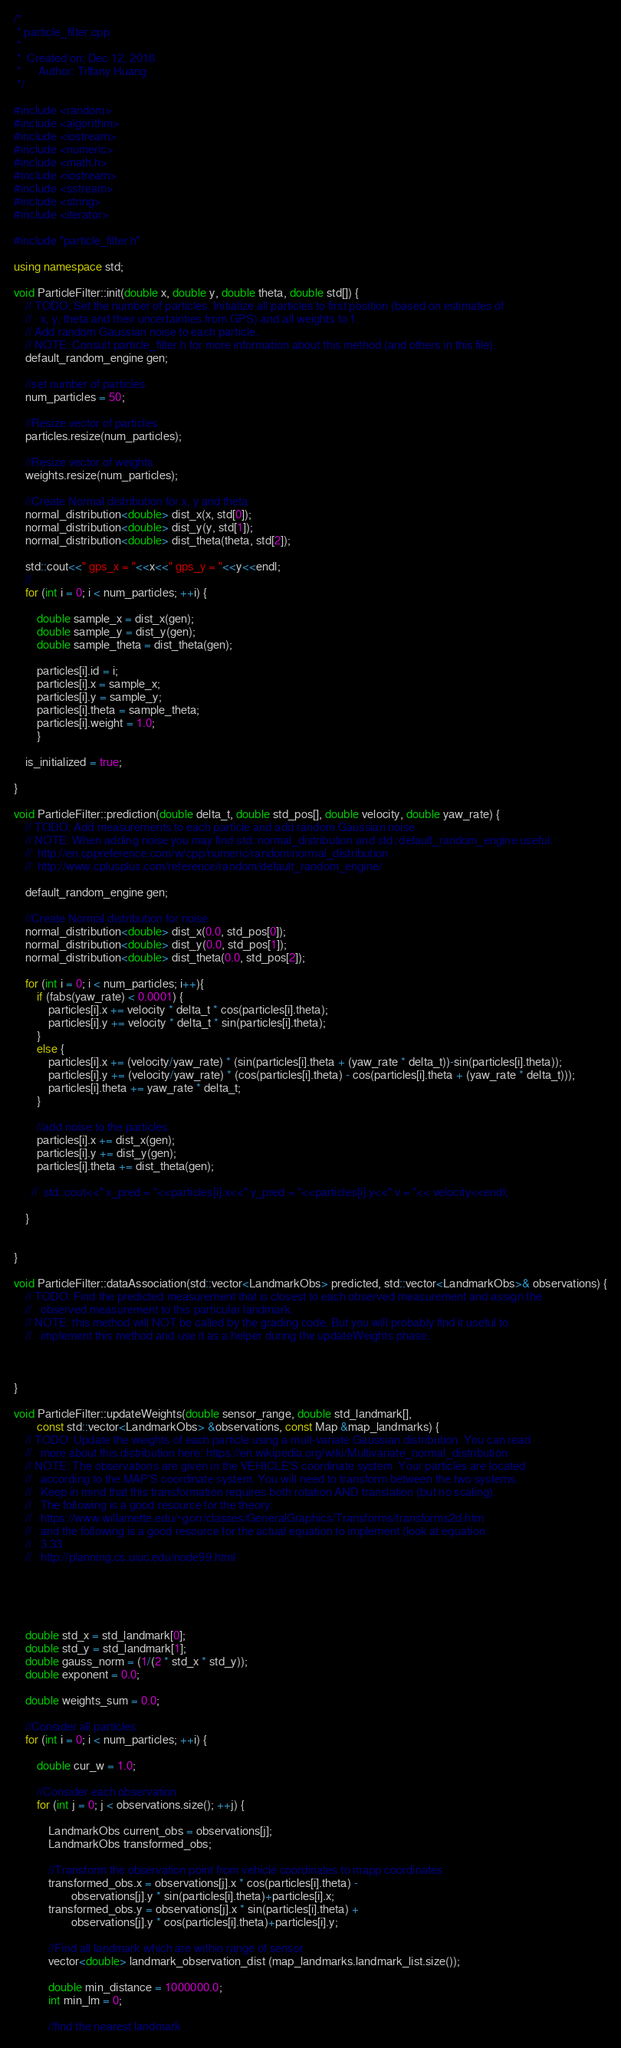<code> <loc_0><loc_0><loc_500><loc_500><_C++_>/*
 * particle_filter.cpp
 *
 *  Created on: Dec 12, 2016
 *      Author: Tiffany Huang
 */

#include <random>
#include <algorithm>
#include <iostream>
#include <numeric>
#include <math.h> 
#include <iostream>
#include <sstream>
#include <string>
#include <iterator>

#include "particle_filter.h"

using namespace std;

void ParticleFilter::init(double x, double y, double theta, double std[]) {
	// TODO: Set the number of particles. Initialize all particles to first position (based on estimates of 
	//   x, y, theta and their uncertainties from GPS) and all weights to 1. 
	// Add random Gaussian noise to each particle.
	// NOTE: Consult particle_filter.h for more information about this method (and others in this file).
    default_random_engine gen;

    //set number of particles
    num_particles = 50;

    //Resize vector of particles
    particles.resize(num_particles);

    //Resize vector of weights
    weights.resize(num_particles);

    //Create Normal distribution for x, y and theta
    normal_distribution<double> dist_x(x, std[0]);
    normal_distribution<double> dist_y(y, std[1]);
    normal_distribution<double> dist_theta(theta, std[2]);

    std::cout<<" gps_x = "<<x<<" gps_y = "<<y<<endl;
    //
    for (int i = 0; i < num_particles; ++i) {

        double sample_x = dist_x(gen);
        double sample_y = dist_y(gen);
        double sample_theta = dist_theta(gen);

        particles[i].id = i;
        particles[i].x = sample_x;
        particles[i].y = sample_y;
        particles[i].theta = sample_theta;
        particles[i].weight = 1.0;
        }

    is_initialized = true;

}

void ParticleFilter::prediction(double delta_t, double std_pos[], double velocity, double yaw_rate) {
	// TODO: Add measurements to each particle and add random Gaussian noise.
	// NOTE: When adding noise you may find std::normal_distribution and std::default_random_engine useful.
	//  http://en.cppreference.com/w/cpp/numeric/random/normal_distribution
	//  http://www.cplusplus.com/reference/random/default_random_engine/

    default_random_engine gen;

    //Create Normal distribution for noise
    normal_distribution<double> dist_x(0.0, std_pos[0]);
    normal_distribution<double> dist_y(0.0, std_pos[1]);
    normal_distribution<double> dist_theta(0.0, std_pos[2]);

    for (int i = 0; i < num_particles; i++){
        if (fabs(yaw_rate) < 0.0001) {
            particles[i].x += velocity * delta_t * cos(particles[i].theta);
            particles[i].y += velocity * delta_t * sin(particles[i].theta);
        }
        else {
            particles[i].x += (velocity/yaw_rate) * (sin(particles[i].theta + (yaw_rate * delta_t))-sin(particles[i].theta));
            particles[i].y += (velocity/yaw_rate) * (cos(particles[i].theta) - cos(particles[i].theta + (yaw_rate * delta_t)));
            particles[i].theta += yaw_rate * delta_t;
        }

        //add noise to the particles
        particles[i].x += dist_x(gen);
        particles[i].y += dist_y(gen);
        particles[i].theta += dist_theta(gen);

      //  std::cout<<" x_pred = "<<particles[i].x<<" y_pred = "<<particles[i].y<<" v = "<< velocity<<endl;

    }


}

void ParticleFilter::dataAssociation(std::vector<LandmarkObs> predicted, std::vector<LandmarkObs>& observations) {
	// TODO: Find the predicted measurement that is closest to each observed measurement and assign the 
	//   observed measurement to this particular landmark.
	// NOTE: this method will NOT be called by the grading code. But you will probably find it useful to 
	//   implement this method and use it as a helper during the updateWeights phase.



}

void ParticleFilter::updateWeights(double sensor_range, double std_landmark[], 
		const std::vector<LandmarkObs> &observations, const Map &map_landmarks) {
	// TODO: Update the weights of each particle using a mult-variate Gaussian distribution. You can read
	//   more about this distribution here: https://en.wikipedia.org/wiki/Multivariate_normal_distribution
	// NOTE: The observations are given in the VEHICLE'S coordinate system. Your particles are located
	//   according to the MAP'S coordinate system. You will need to transform between the two systems.
	//   Keep in mind that this transformation requires both rotation AND translation (but no scaling).
	//   The following is a good resource for the theory:
	//   https://www.willamette.edu/~gorr/classes/GeneralGraphics/Transforms/transforms2d.htm
	//   and the following is a good resource for the actual equation to implement (look at equation 
	//   3.33
	//   http://planning.cs.uiuc.edu/node99.html





    double std_x = std_landmark[0];
    double std_y = std_landmark[1];
    double gauss_norm = (1/(2 * std_x * std_y));
    double exponent = 0.0;

    double weights_sum = 0.0;

    //Consider all particles
    for (int i = 0; i < num_particles; ++i) {

        double cur_w = 1.0;

        //Consider each observation
        for (int j = 0; j < observations.size(); ++j) {

            LandmarkObs current_obs = observations[j];
            LandmarkObs transformed_obs;

            //Transform the observation point from vehicle coordinates to mapp coordinates
            transformed_obs.x = observations[j].x * cos(particles[i].theta) -
                    observations[j].y * sin(particles[i].theta)+particles[i].x;
            transformed_obs.y = observations[j].x * sin(particles[i].theta) +
                    observations[j].y * cos(particles[i].theta)+particles[i].y;

            //Find all landmark which are within range of sensor
            vector<double> landmark_observation_dist (map_landmarks.landmark_list.size());

            double min_distance = 1000000.0;
            int min_lm = 0;

            //find the nearest landmark</code> 